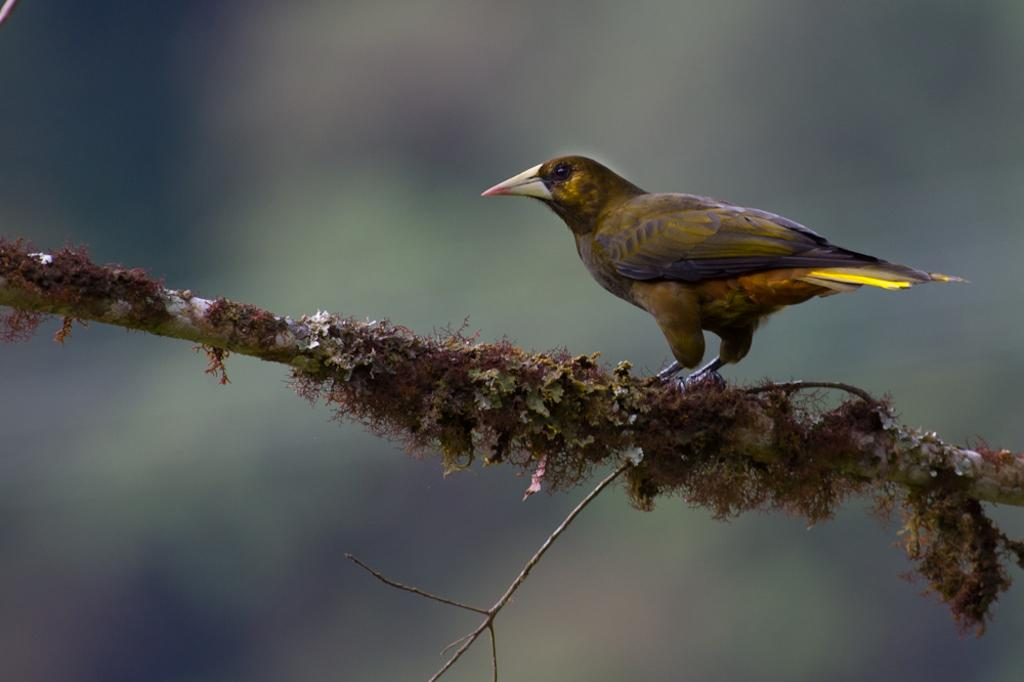What type of animal can be seen in the image? There is a bird in the image. What material is the object in the image made of? The object in the image is made of wood. Can you describe the background of the image? The background of the image is blurred. How does the bird work in the image? The bird is not working in the image; it is a living creature and not performing any tasks or actions related to work. 